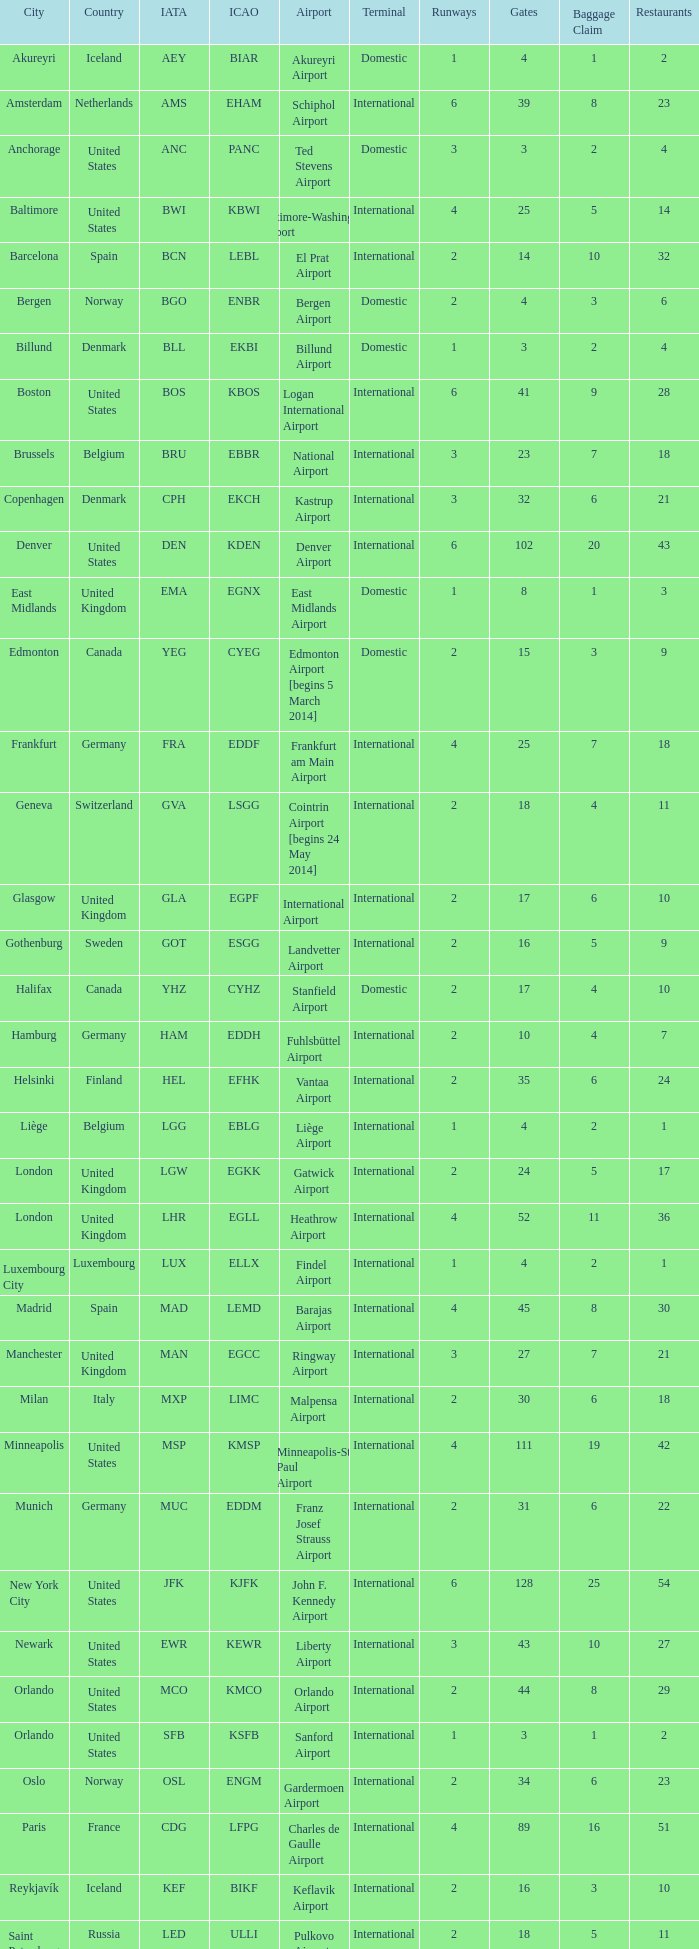What Airport's IATA is SEA? Seattle–Tacoma Airport. 